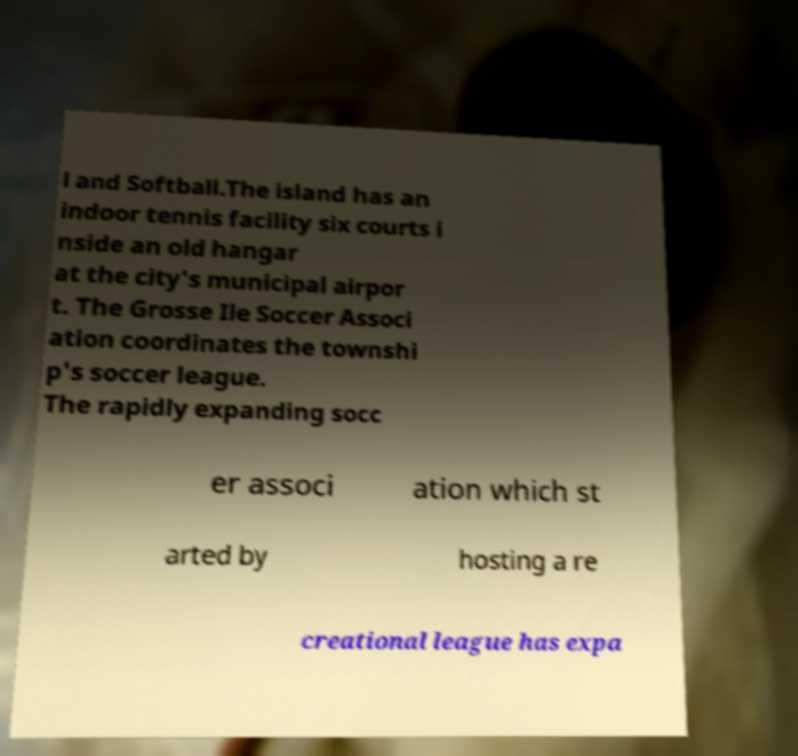I need the written content from this picture converted into text. Can you do that? l and Softball.The island has an indoor tennis facility six courts i nside an old hangar at the city's municipal airpor t. The Grosse Ile Soccer Associ ation coordinates the townshi p's soccer league. The rapidly expanding socc er associ ation which st arted by hosting a re creational league has expa 